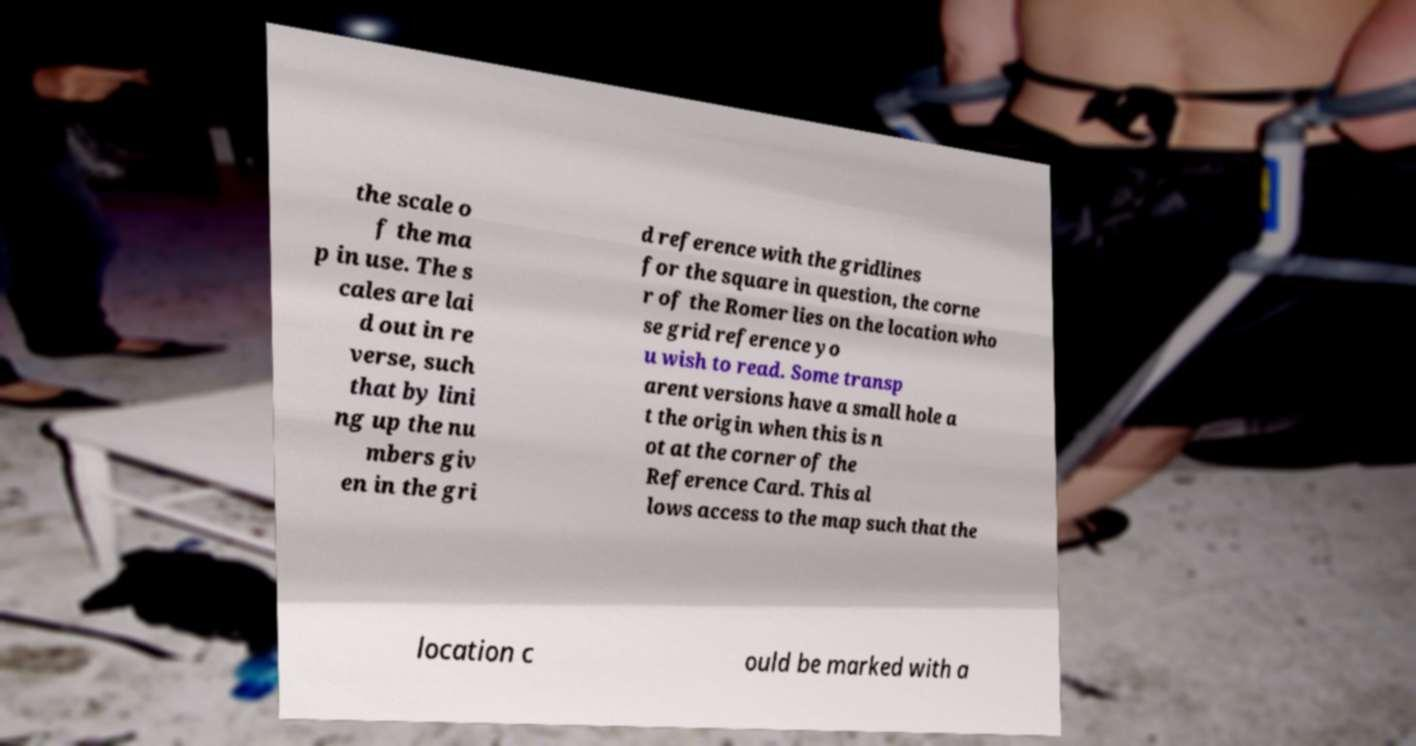For documentation purposes, I need the text within this image transcribed. Could you provide that? the scale o f the ma p in use. The s cales are lai d out in re verse, such that by lini ng up the nu mbers giv en in the gri d reference with the gridlines for the square in question, the corne r of the Romer lies on the location who se grid reference yo u wish to read. Some transp arent versions have a small hole a t the origin when this is n ot at the corner of the Reference Card. This al lows access to the map such that the location c ould be marked with a 